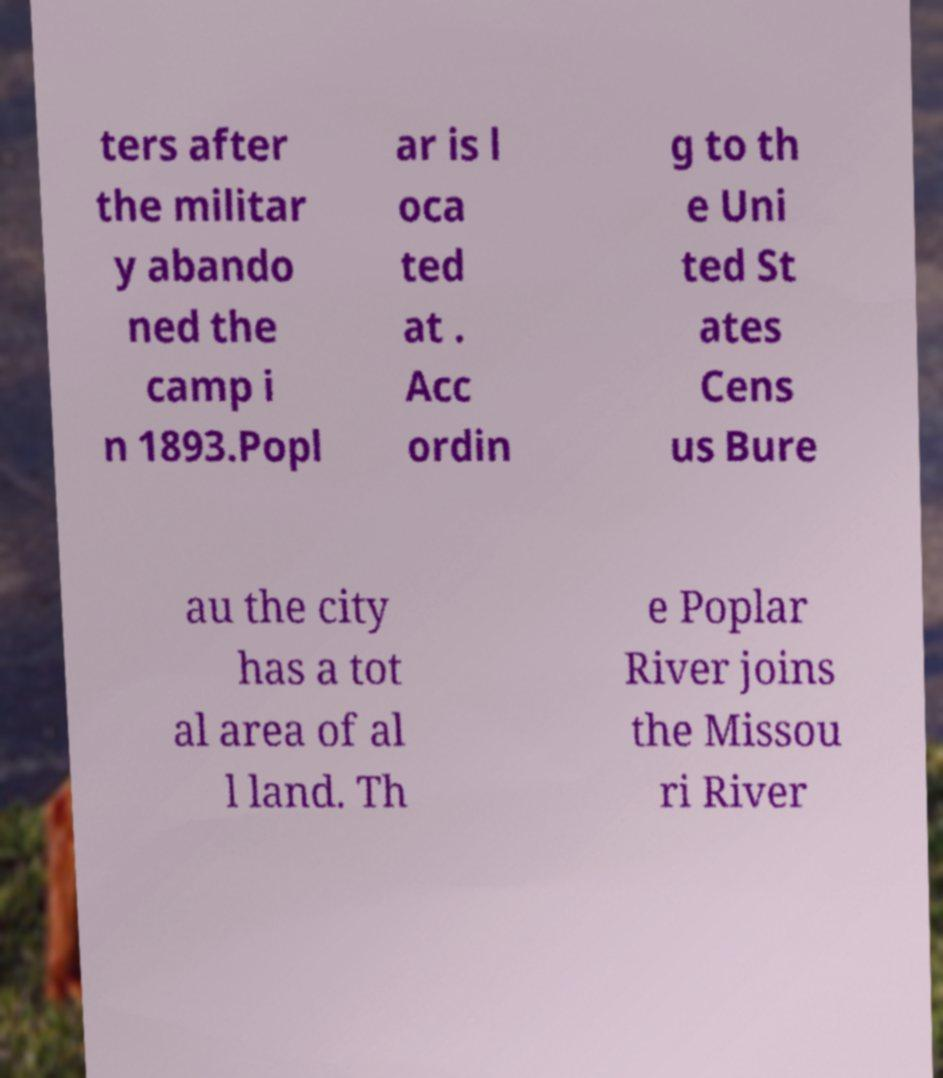For documentation purposes, I need the text within this image transcribed. Could you provide that? ters after the militar y abando ned the camp i n 1893.Popl ar is l oca ted at . Acc ordin g to th e Uni ted St ates Cens us Bure au the city has a tot al area of al l land. Th e Poplar River joins the Missou ri River 